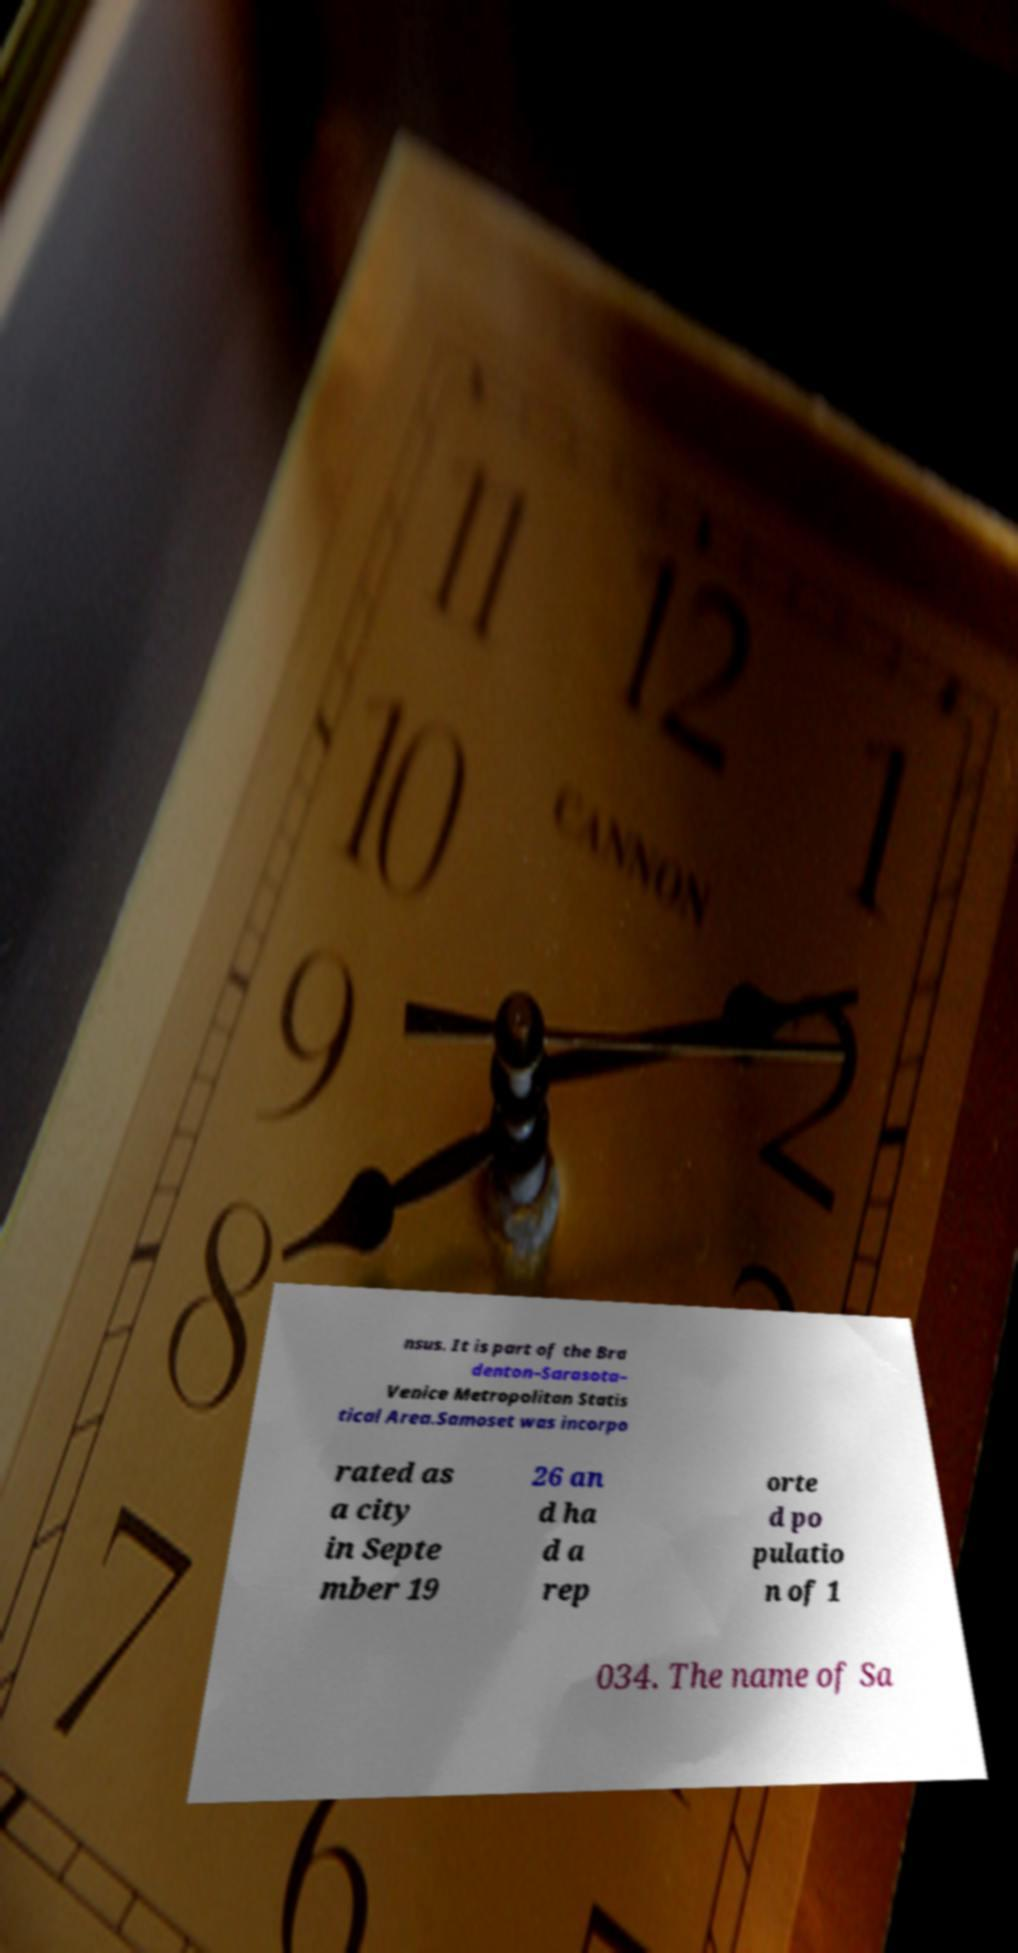Could you assist in decoding the text presented in this image and type it out clearly? nsus. It is part of the Bra denton–Sarasota– Venice Metropolitan Statis tical Area.Samoset was incorpo rated as a city in Septe mber 19 26 an d ha d a rep orte d po pulatio n of 1 034. The name of Sa 